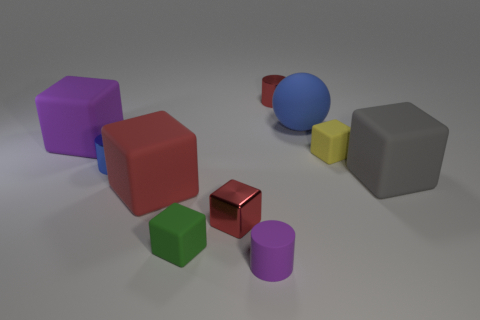Subtract all yellow cylinders. How many red cubes are left? 2 Subtract all small metal cubes. How many cubes are left? 5 Subtract 1 cubes. How many cubes are left? 5 Subtract all red cubes. How many cubes are left? 4 Subtract all gray cylinders. Subtract all cyan cubes. How many cylinders are left? 3 Subtract all cylinders. How many objects are left? 7 Add 3 small red cubes. How many small red cubes exist? 4 Subtract 0 yellow balls. How many objects are left? 10 Subtract all big blue spheres. Subtract all big blue balls. How many objects are left? 8 Add 1 blue matte spheres. How many blue matte spheres are left? 2 